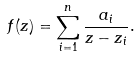<formula> <loc_0><loc_0><loc_500><loc_500>f ( z ) = \sum _ { i = 1 } ^ { n } \frac { a _ { i } } { z - z _ { i } } .</formula> 